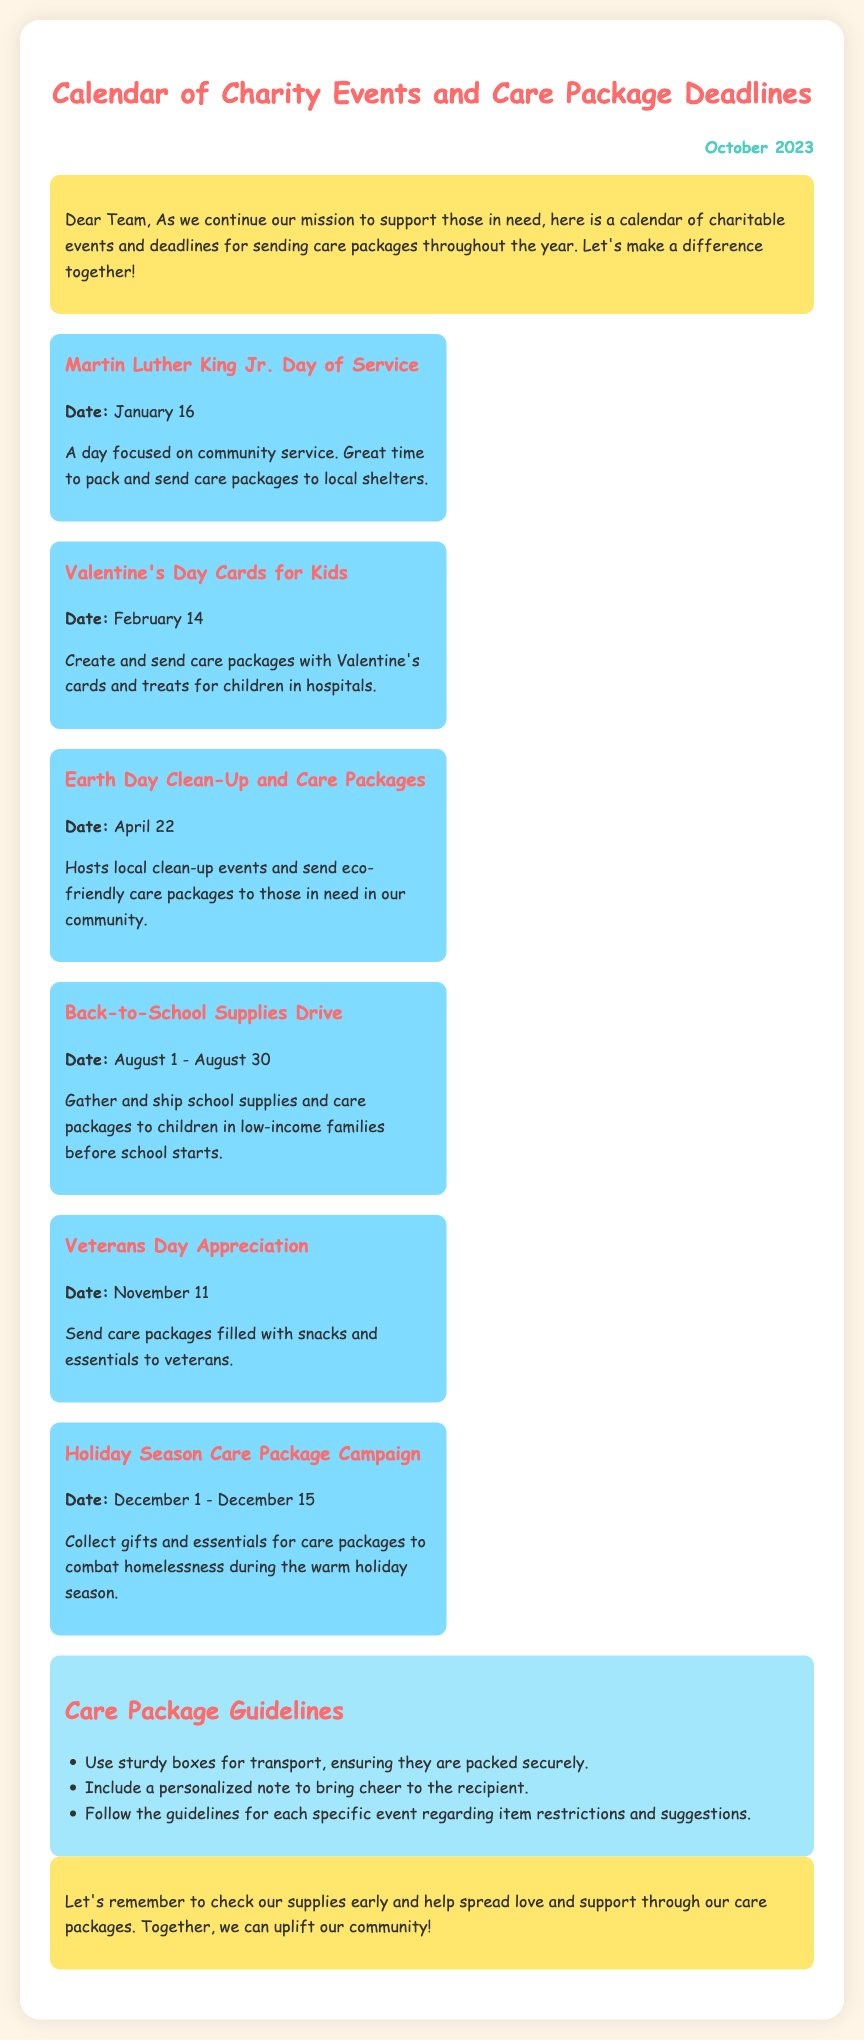What is the first charity event listed? The first charity event is Martin Luther King Jr. Day of Service, which is mentioned at the top of the events section.
Answer: Martin Luther King Jr. Day of Service When is Valentine's Day? Valentine's Day is listed with the date right under the event title.
Answer: February 14 What should be included in care packages according to the guidelines? The guidelines specify including a personalized note to bring cheer to the recipient as one of the suggested items.
Answer: A personalized note How long does the Holiday Season Care Package Campaign last? The campaign dates are provided, indicating its duration from December 1 to December 15.
Answer: December 1 - December 15 What event is focused on sending eco-friendly care packages? The event that highlights eco-friendly care packages is Earth Day Clean-Up and Care Packages, as stated in the description.
Answer: Earth Day Clean-Up and Care Packages Which charity event comes right before Veterans Day? By looking at the timeline of events, the event right before Veterans Day is the Back-to-School Supplies Drive in August.
Answer: Back-to-School Supplies Drive How many weeks do we have for the Back-to-School Supplies Drive? The event spans from August 1 to August 30, indicating a duration of 30 days or about 4 weeks.
Answer: 30 days What color theme is used throughout the document? The document features a color scheme that includes soft pastel colors, primarily focusing on shades of pink and blue.
Answer: Soft pastel colors 